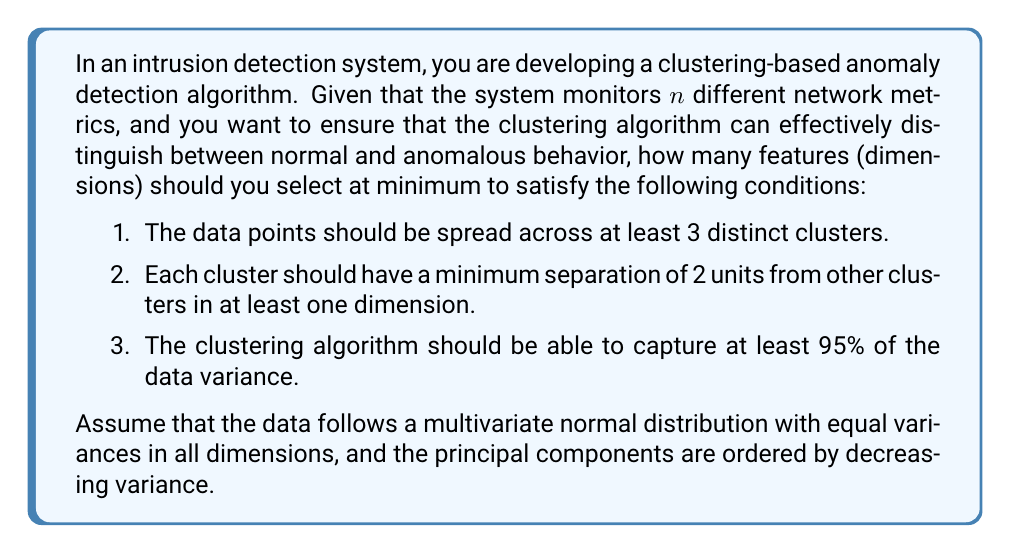Can you answer this question? To solve this problem, we need to consider the requirements of clustering and dimensionality reduction techniques in the context of anomaly detection. Let's break down the solution step by step:

1. Cluster separation:
   The requirement for at least 3 distinct clusters with a minimum separation of 2 units in at least one dimension suggests that we need at least 2 dimensions to satisfy this condition. This is because in a single dimension, we can only separate points linearly, which wouldn't allow for 3 distinct clusters with the given separation.

2. Variance capture:
   To determine the number of dimensions needed to capture 95% of the data variance, we need to use the concept of Principal Component Analysis (PCA). In PCA, the principal components are ordered by decreasing variance, and we need to find the number of components that cumulatively explain at least 95% of the total variance.

   Given that the data follows a multivariate normal distribution with equal variances in all dimensions, we can use the properties of the normal distribution to calculate the cumulative variance explained.

   Let $\lambda_i$ be the variance explained by the $i$-th principal component. For equal variances, we have:

   $$\lambda_i = \frac{n - i + 1}{n}, \quad i = 1, 2, ..., n$$

   The cumulative variance explained by the first $k$ components is:

   $$\text{Cumulative Variance} = \frac{\sum_{i=1}^k \lambda_i}{\sum_{i=1}^n \lambda_i} = \frac{\sum_{i=1}^k (n - i + 1)}{n^2}$$

   We need to find the smallest $k$ such that:

   $$\frac{\sum_{i=1}^k (n - i + 1)}{n^2} \geq 0.95$$

   This can be simplified to:

   $$\frac{kn - \frac{k(k-1)}{2}}{n^2} \geq 0.95$$

   Solving this inequality for different values of $k$, we find that $k = 3$ is the minimum number of dimensions needed to capture at least 95% of the variance for any $n \geq 3$.

3. Combining the requirements:
   We need at least 2 dimensions for cluster separation and at least 3 dimensions to capture 95% of the variance. Therefore, the minimum number of features needed is the maximum of these two values, which is 3.
Answer: The minimum number of features needed for effective clustering in anomaly detection, given the specified conditions, is 3. 